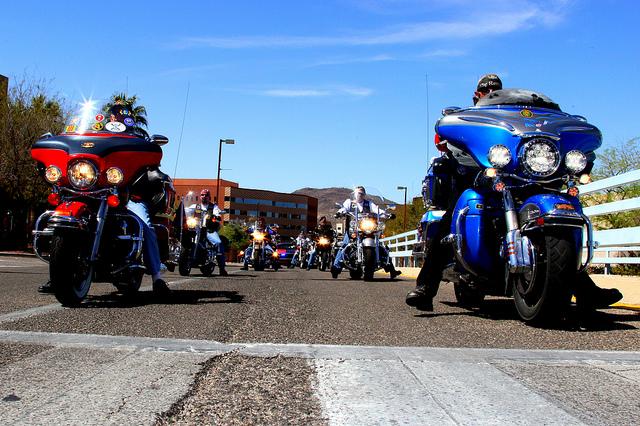Are the bikes in motion?
Be succinct. No. Are these people ready to race?
Concise answer only. Yes. How many red scooters are in the scene?
Short answer required. 1. How many light poles?
Be succinct. 2. 